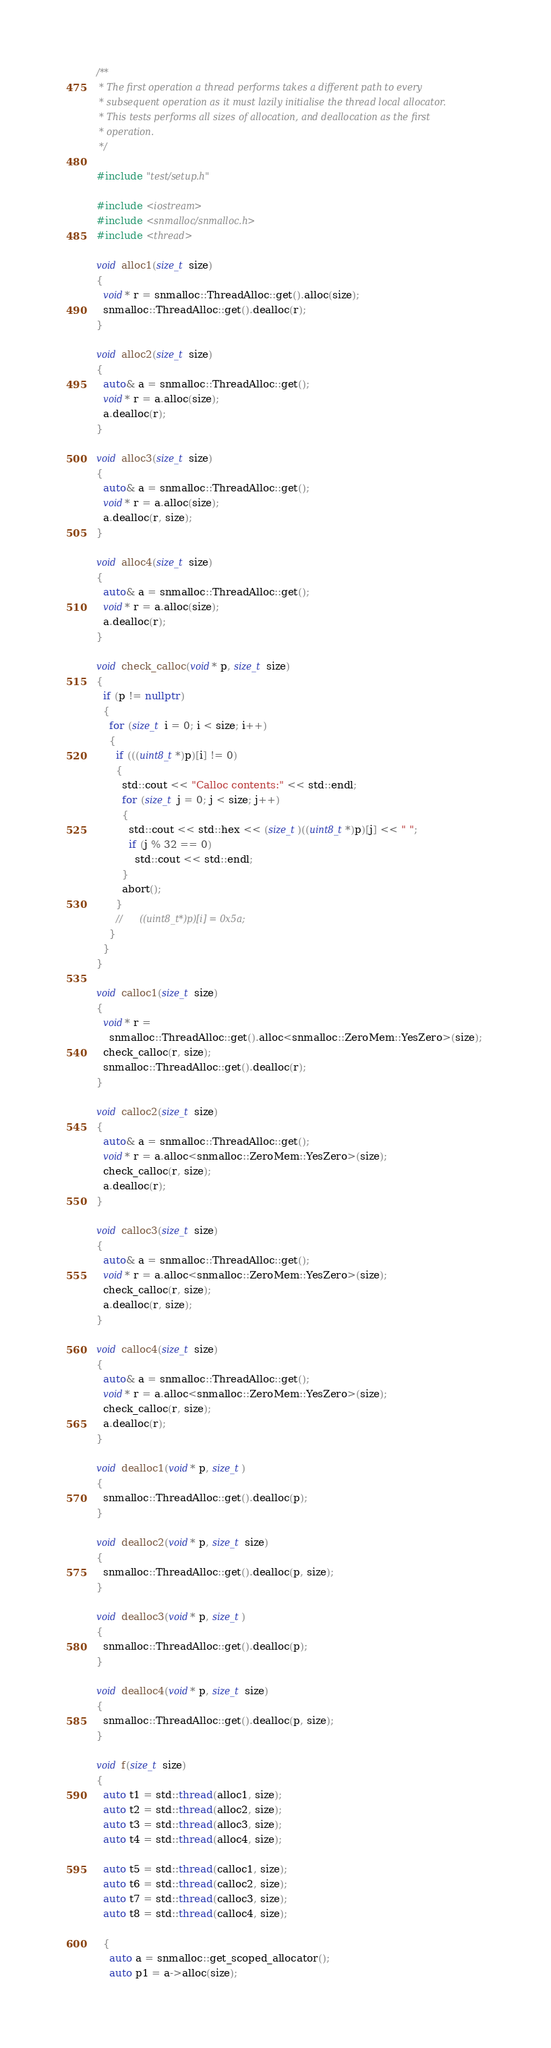<code> <loc_0><loc_0><loc_500><loc_500><_C++_>/**
 * The first operation a thread performs takes a different path to every
 * subsequent operation as it must lazily initialise the thread local allocator.
 * This tests performs all sizes of allocation, and deallocation as the first
 * operation.
 */

#include "test/setup.h"

#include <iostream>
#include <snmalloc/snmalloc.h>
#include <thread>

void alloc1(size_t size)
{
  void* r = snmalloc::ThreadAlloc::get().alloc(size);
  snmalloc::ThreadAlloc::get().dealloc(r);
}

void alloc2(size_t size)
{
  auto& a = snmalloc::ThreadAlloc::get();
  void* r = a.alloc(size);
  a.dealloc(r);
}

void alloc3(size_t size)
{
  auto& a = snmalloc::ThreadAlloc::get();
  void* r = a.alloc(size);
  a.dealloc(r, size);
}

void alloc4(size_t size)
{
  auto& a = snmalloc::ThreadAlloc::get();
  void* r = a.alloc(size);
  a.dealloc(r);
}

void check_calloc(void* p, size_t size)
{
  if (p != nullptr)
  {
    for (size_t i = 0; i < size; i++)
    {
      if (((uint8_t*)p)[i] != 0)
      {
        std::cout << "Calloc contents:" << std::endl;
        for (size_t j = 0; j < size; j++)
        {
          std::cout << std::hex << (size_t)((uint8_t*)p)[j] << " ";
          if (j % 32 == 0)
            std::cout << std::endl;
        }
        abort();
      }
      //      ((uint8_t*)p)[i] = 0x5a;
    }
  }
}

void calloc1(size_t size)
{
  void* r =
    snmalloc::ThreadAlloc::get().alloc<snmalloc::ZeroMem::YesZero>(size);
  check_calloc(r, size);
  snmalloc::ThreadAlloc::get().dealloc(r);
}

void calloc2(size_t size)
{
  auto& a = snmalloc::ThreadAlloc::get();
  void* r = a.alloc<snmalloc::ZeroMem::YesZero>(size);
  check_calloc(r, size);
  a.dealloc(r);
}

void calloc3(size_t size)
{
  auto& a = snmalloc::ThreadAlloc::get();
  void* r = a.alloc<snmalloc::ZeroMem::YesZero>(size);
  check_calloc(r, size);
  a.dealloc(r, size);
}

void calloc4(size_t size)
{
  auto& a = snmalloc::ThreadAlloc::get();
  void* r = a.alloc<snmalloc::ZeroMem::YesZero>(size);
  check_calloc(r, size);
  a.dealloc(r);
}

void dealloc1(void* p, size_t)
{
  snmalloc::ThreadAlloc::get().dealloc(p);
}

void dealloc2(void* p, size_t size)
{
  snmalloc::ThreadAlloc::get().dealloc(p, size);
}

void dealloc3(void* p, size_t)
{
  snmalloc::ThreadAlloc::get().dealloc(p);
}

void dealloc4(void* p, size_t size)
{
  snmalloc::ThreadAlloc::get().dealloc(p, size);
}

void f(size_t size)
{
  auto t1 = std::thread(alloc1, size);
  auto t2 = std::thread(alloc2, size);
  auto t3 = std::thread(alloc3, size);
  auto t4 = std::thread(alloc4, size);

  auto t5 = std::thread(calloc1, size);
  auto t6 = std::thread(calloc2, size);
  auto t7 = std::thread(calloc3, size);
  auto t8 = std::thread(calloc4, size);

  {
    auto a = snmalloc::get_scoped_allocator();
    auto p1 = a->alloc(size);</code> 